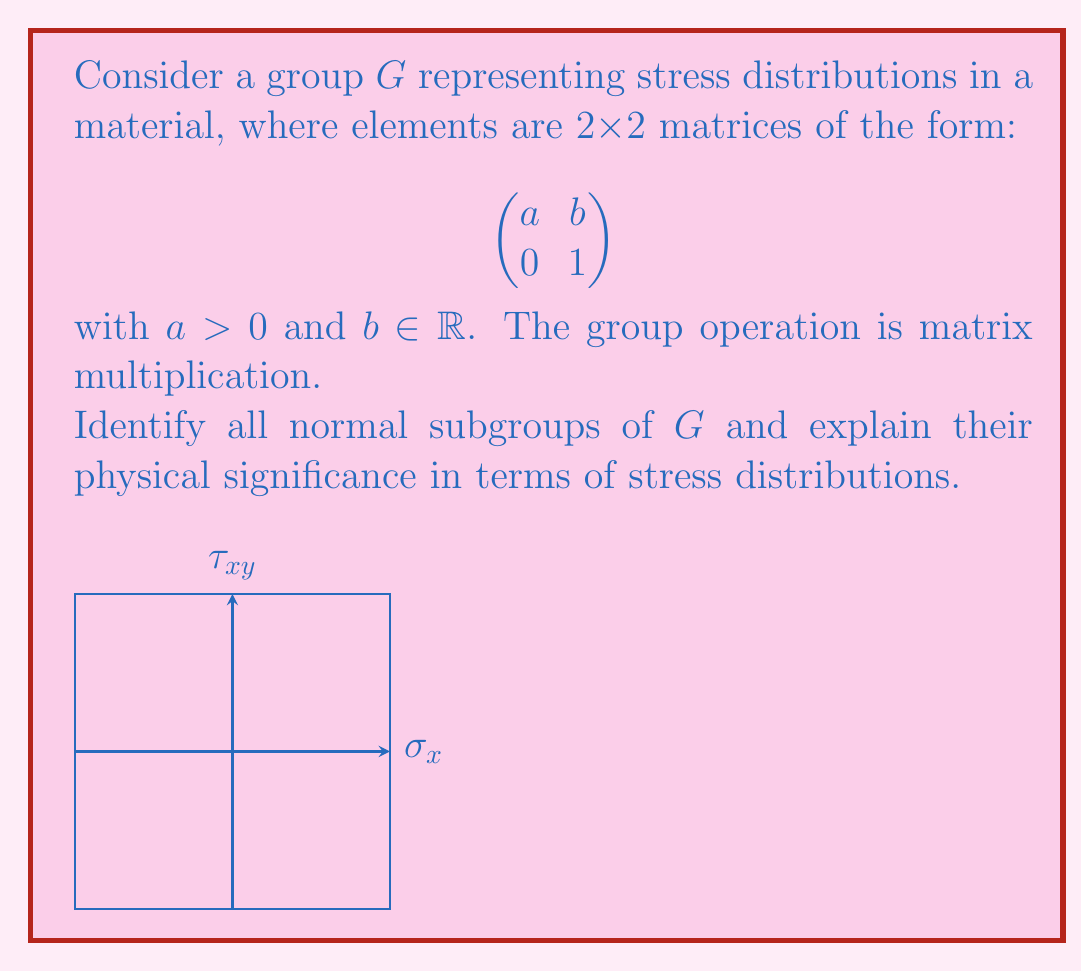Can you solve this math problem? To identify the normal subgroups of $G$, we'll follow these steps:

1) First, let's understand the group structure:
   - The identity element is $\begin{pmatrix} 1 & 0 \\ 0 & 1 \end{pmatrix}$
   - A general element is $\begin{pmatrix} a & b \\ 0 & 1 \end{pmatrix}$ where $a > 0$ and $b \in \mathbb{R}$

2) Now, let's consider potential subgroups:

   a) $H_1 = \{\begin{pmatrix} 1 & b \\ 0 & 1 \end{pmatrix} | b \in \mathbb{R}\}$
      This represents pure shear stress distributions.

   b) $H_2 = \{\begin{pmatrix} a & 0 \\ 0 & 1 \end{pmatrix} | a > 0\}$
      This represents pure normal stress distributions.

   c) $H_3 = \{\begin{pmatrix} 1 & 0 \\ 0 & 1 \end{pmatrix}\}$
      The trivial subgroup.

3) To check if these are normal subgroups, we need to verify if $gHg^{-1} = H$ for all $g \in G$ and $H$ being the subgroup.

4) For $H_1$:
   Let $g = \begin{pmatrix} a & c \\ 0 & 1 \end{pmatrix}$ and $h = \begin{pmatrix} 1 & b \\ 0 & 1 \end{pmatrix}$
   $ghg^{-1} = \begin{pmatrix} a & c \\ 0 & 1 \end{pmatrix} \begin{pmatrix} 1 & b \\ 0 & 1 \end{pmatrix} \begin{pmatrix} 1/a & -c/a \\ 0 & 1 \end{pmatrix} = \begin{pmatrix} 1 & b \\ 0 & 1 \end{pmatrix}$
   This shows that $H_1$ is a normal subgroup.

5) For $H_2$:
   $ghg^{-1} = \begin{pmatrix} a & c \\ 0 & 1 \end{pmatrix} \begin{pmatrix} k & 0 \\ 0 & 1 \end{pmatrix} \begin{pmatrix} 1/a & -c/a \\ 0 & 1 \end{pmatrix} = \begin{pmatrix} k & c(1-k)/a \\ 0 & 1 \end{pmatrix}$
   This is not always in $H_2$, so $H_2$ is not a normal subgroup.

6) $H_3$ is always a normal subgroup as it's the trivial subgroup.

Physical significance:
- $H_1$ represents pure shear stress distributions, which are invariant under transformations in $G$. This means that pure shear components are preserved under the stress transformations represented by $G$.
- $H_3$, being the trivial subgroup, represents the stress-free state, which is invariant under all transformations.
Answer: The normal subgroups are $H_1 = \{\begin{pmatrix} 1 & b \\ 0 & 1 \end{pmatrix} | b \in \mathbb{R}\}$ and $H_3 = \{\begin{pmatrix} 1 & 0 \\ 0 & 1 \end{pmatrix}\}$, representing pure shear stress distributions and the stress-free state, respectively. 